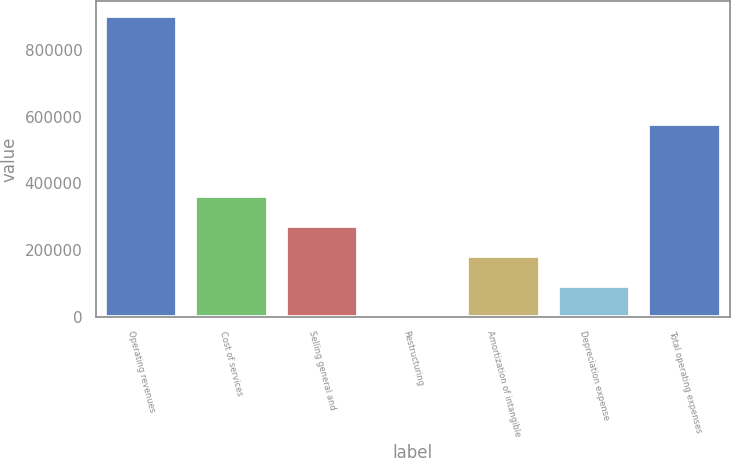<chart> <loc_0><loc_0><loc_500><loc_500><bar_chart><fcel>Operating revenues<fcel>Cost of services<fcel>Selling general and<fcel>Restructuring<fcel>Amortization of intangible<fcel>Depreciation expense<fcel>Total operating expenses<nl><fcel>900941<fcel>362533<fcel>272798<fcel>3594<fcel>183063<fcel>93328.7<fcel>578943<nl></chart> 